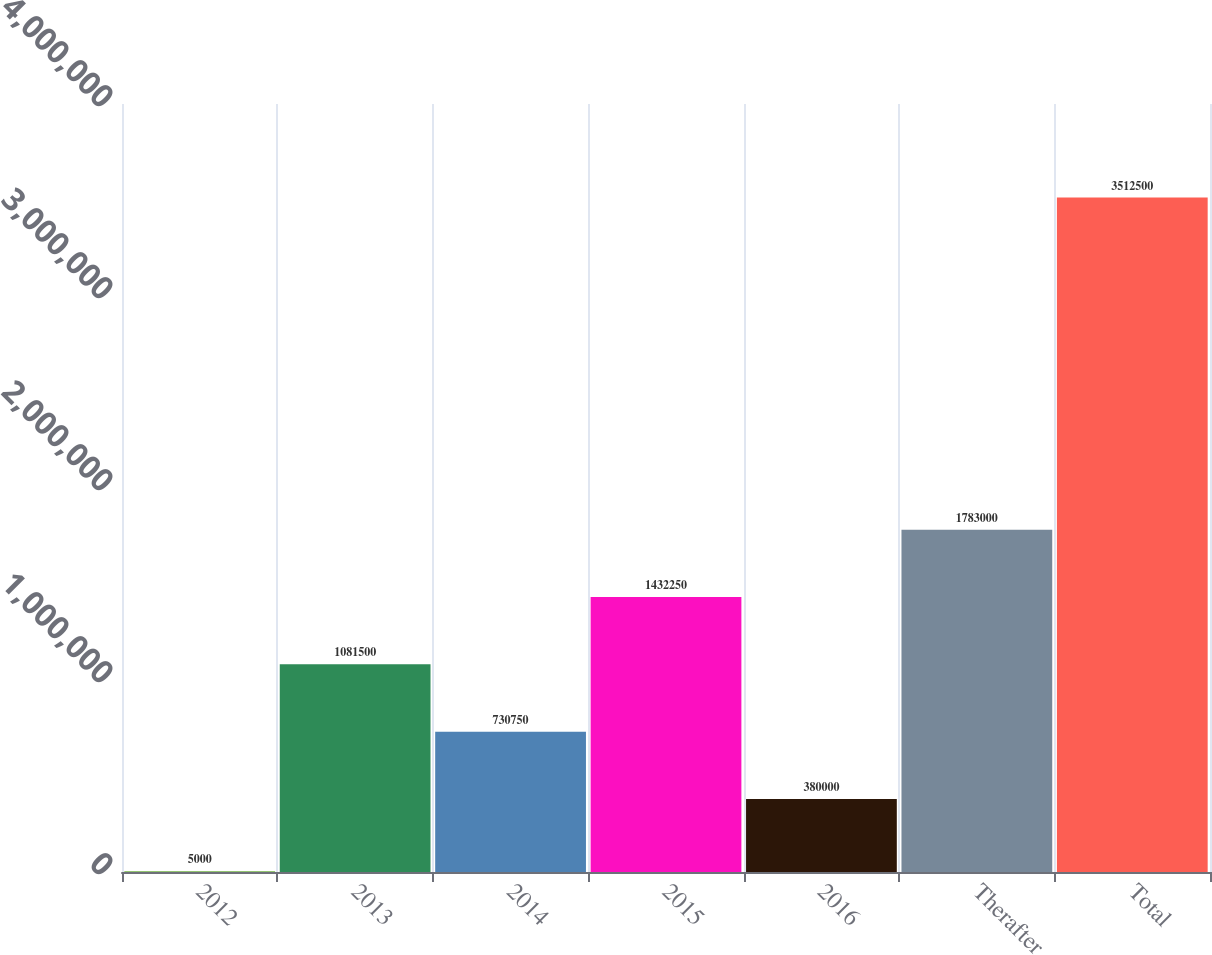Convert chart to OTSL. <chart><loc_0><loc_0><loc_500><loc_500><bar_chart><fcel>2012<fcel>2013<fcel>2014<fcel>2015<fcel>2016<fcel>Therafter<fcel>Total<nl><fcel>5000<fcel>1.0815e+06<fcel>730750<fcel>1.43225e+06<fcel>380000<fcel>1.783e+06<fcel>3.5125e+06<nl></chart> 